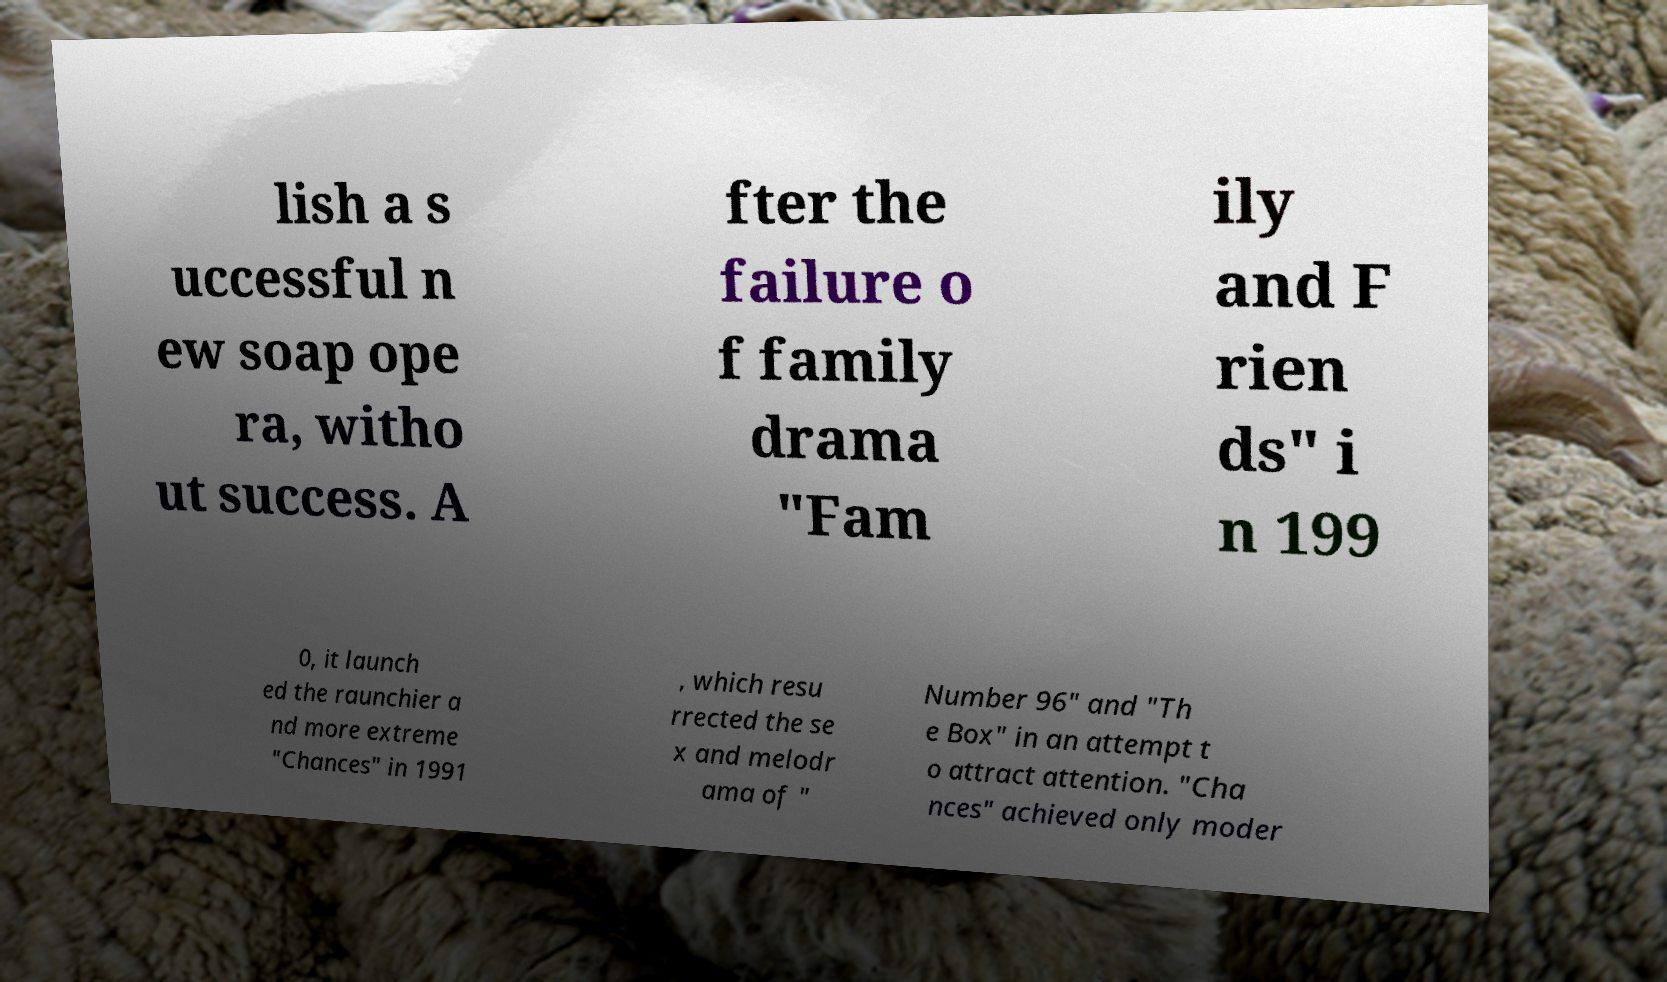I need the written content from this picture converted into text. Can you do that? lish a s uccessful n ew soap ope ra, witho ut success. A fter the failure o f family drama "Fam ily and F rien ds" i n 199 0, it launch ed the raunchier a nd more extreme "Chances" in 1991 , which resu rrected the se x and melodr ama of " Number 96" and "Th e Box" in an attempt t o attract attention. "Cha nces" achieved only moder 